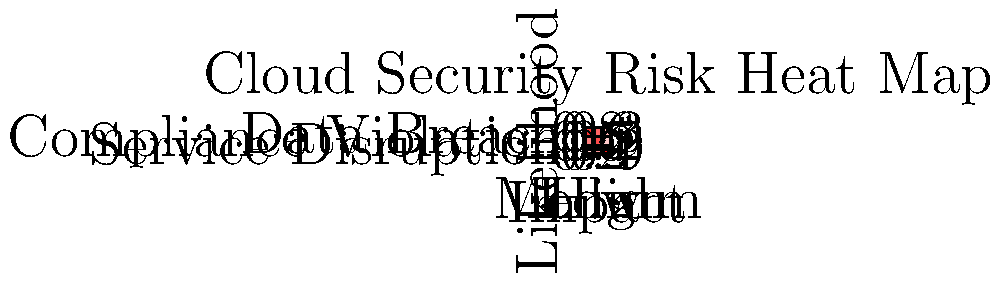Based on the heat map visualization of cloud security risks for a government agency migrating data to the cloud, which risk category poses the highest threat and requires immediate attention? To determine the highest risk category requiring immediate attention, we need to analyze the heat map visualization:

1. Understand the heat map structure:
   - X-axis represents Impact (Low, Medium, High)
   - Y-axis represents Likelihood (Data Breach, Compliance Violation, Service Disruption)
   - Color intensity indicates risk level (darker red = higher risk)

2. Examine each risk category:
   a) Data Breach:
      - Low Impact: 0.8 (high likelihood)
      - Medium Impact: 0.6 (medium likelihood)
      - High Impact: 0.3 (low likelihood)
   
   b) Compliance Violation:
      - Low Impact: 0.5 (medium likelihood)
      - Medium Impact: 0.7 (high likelihood)
      - High Impact: 0.2 (low likelihood)
   
   c) Service Disruption:
      - Low Impact: 0.2 (low likelihood)
      - Medium Impact: 0.4 (medium likelihood)
      - High Impact: 0.9 (very high likelihood)

3. Identify the highest risk:
   - The darkest red cell in the heat map is in the Service Disruption row and High Impact column, with a value of 0.9.

4. Interpret the result:
   - This indicates that Service Disruption with High Impact has the highest likelihood (0.9) among all risk categories.

5. Consider the context:
   - For a government agency migrating data to the cloud, a high-impact service disruption could severely affect operations and public services.

Therefore, the risk category that poses the highest threat and requires immediate attention is Service Disruption with High Impact.
Answer: Service Disruption with High Impact 